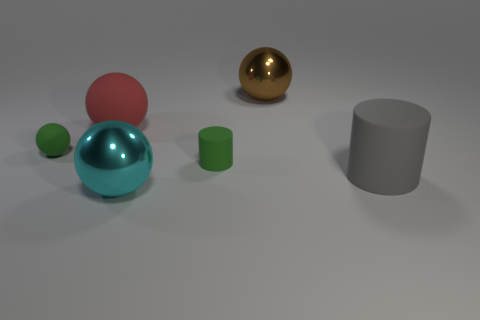What color is the big ball in front of the large matte thing to the right of the shiny thing on the left side of the brown metallic object? cyan 